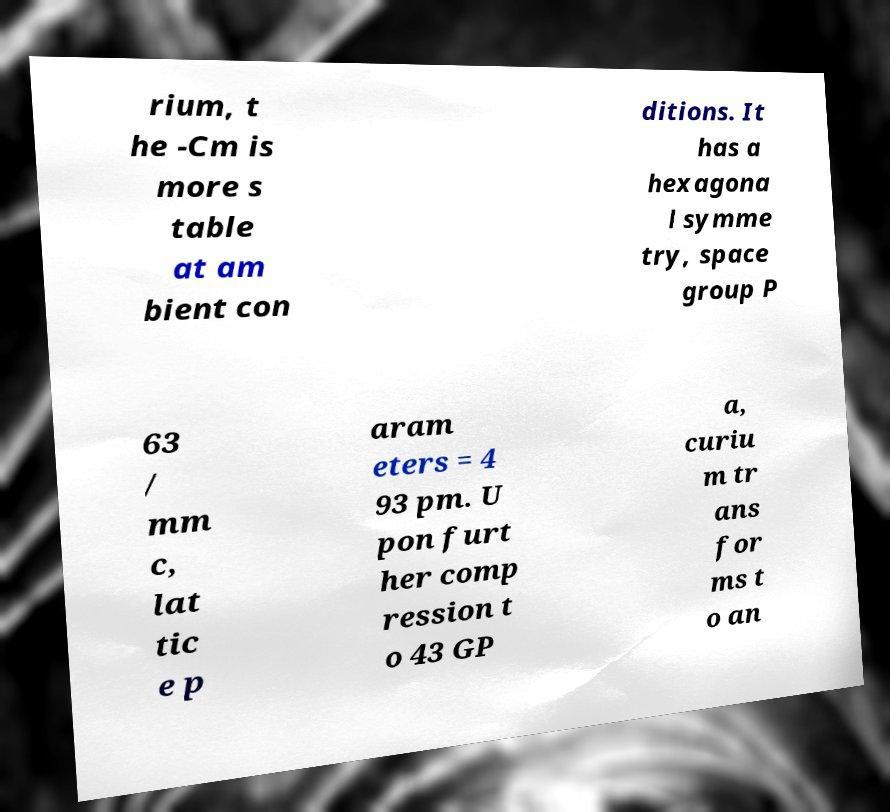Can you read and provide the text displayed in the image?This photo seems to have some interesting text. Can you extract and type it out for me? rium, t he -Cm is more s table at am bient con ditions. It has a hexagona l symme try, space group P 63 / mm c, lat tic e p aram eters = 4 93 pm. U pon furt her comp ression t o 43 GP a, curiu m tr ans for ms t o an 